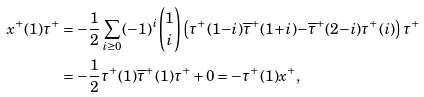<formula> <loc_0><loc_0><loc_500><loc_500>x ^ { + } ( 1 ) \tau ^ { + } & = - \frac { 1 } { 2 } \sum _ { i \geq 0 } ( - 1 ) ^ { i } \binom { 1 } { i } \left ( \tau ^ { + } ( 1 { - } i ) \overline { \tau } ^ { + } ( 1 { + } i ) { - } \overline { \tau } ^ { + } ( 2 { - } i ) { \tau } ^ { + } ( i ) \right ) \tau ^ { + } \\ & = - \frac { 1 } { 2 } \tau ^ { + } ( 1 ) \overline { \tau } ^ { + } ( 1 ) \tau ^ { + } + 0 = - \tau ^ { + } ( 1 ) x ^ { + } ,</formula> 